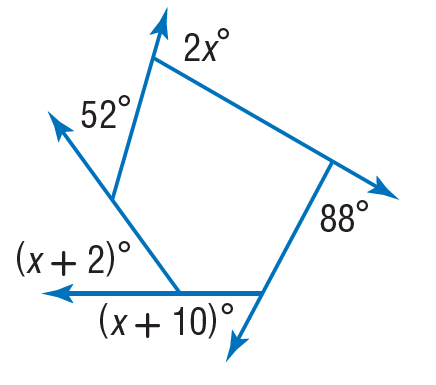Answer the mathemtical geometry problem and directly provide the correct option letter.
Question: Find the value of x in the diagram.
Choices: A: 12 B: 52 C: 88 D: 120 B 